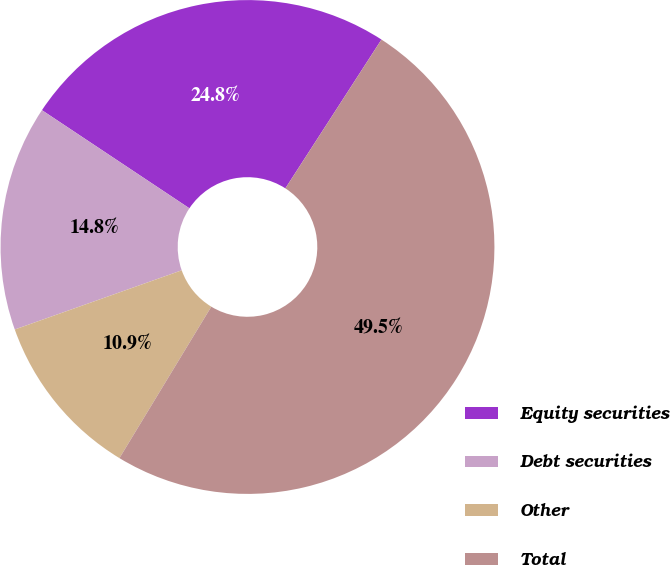<chart> <loc_0><loc_0><loc_500><loc_500><pie_chart><fcel>Equity securities<fcel>Debt securities<fcel>Other<fcel>Total<nl><fcel>24.78%<fcel>14.77%<fcel>10.9%<fcel>49.55%<nl></chart> 